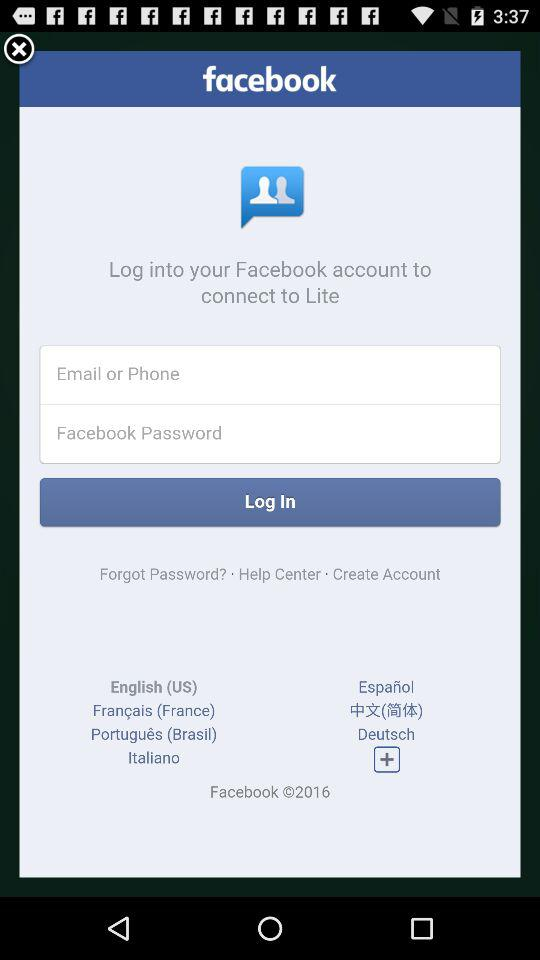What application page is this?
Answer the question using a single word or phrase. It is "facebook". 